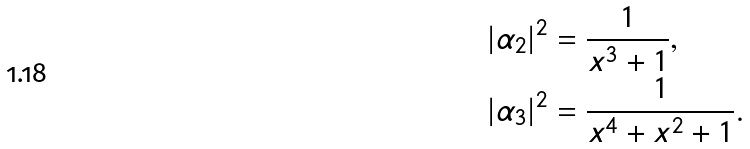<formula> <loc_0><loc_0><loc_500><loc_500>| \alpha _ { 2 } | ^ { 2 } & = \frac { 1 } { x ^ { 3 } + 1 } , \\ | \alpha _ { 3 } | ^ { 2 } & = \frac { 1 } { x ^ { 4 } + x ^ { 2 } + 1 } .</formula> 